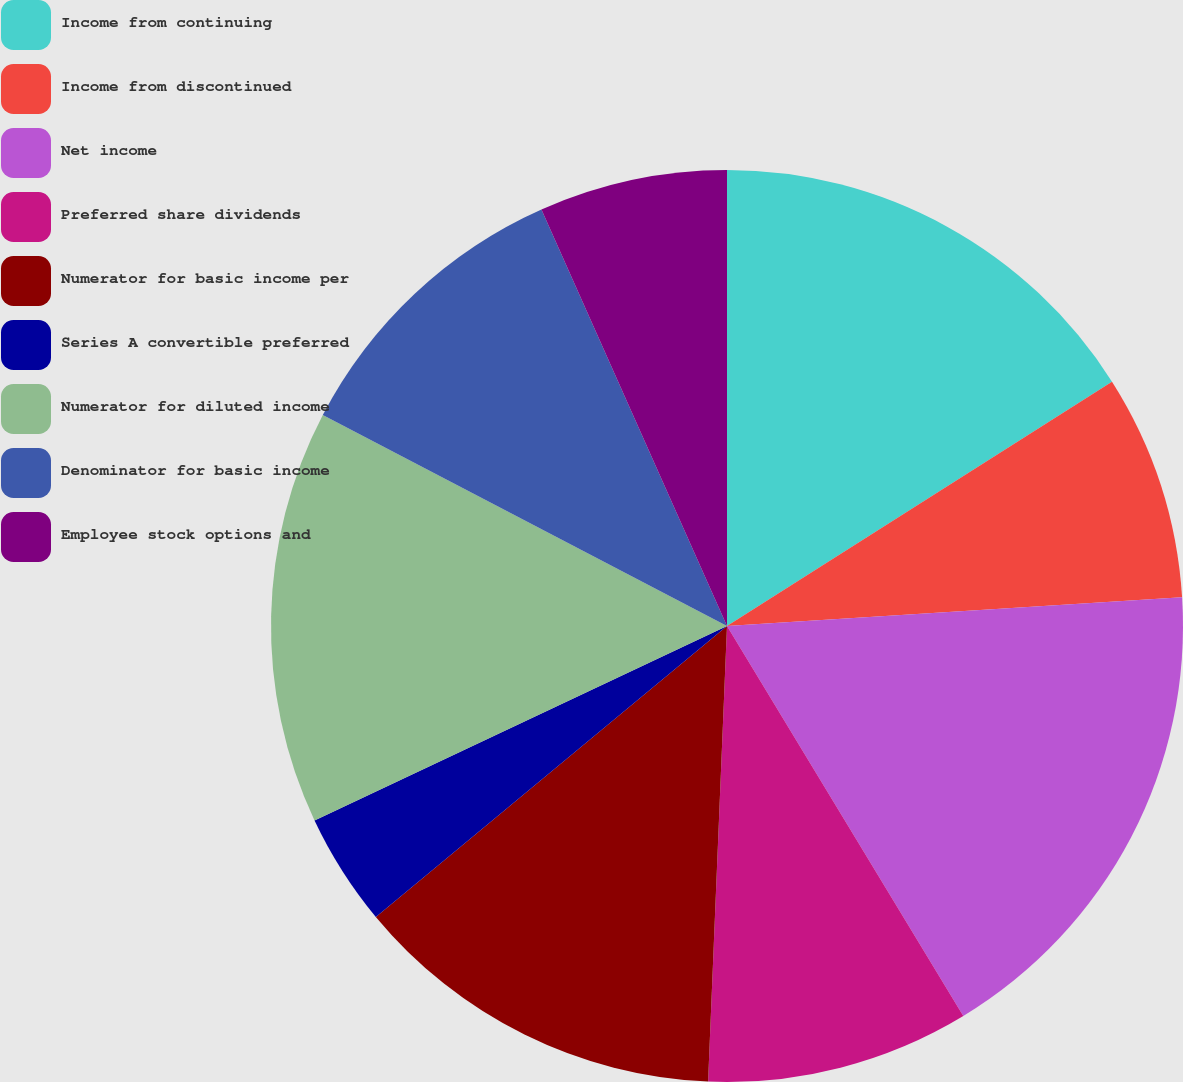Convert chart. <chart><loc_0><loc_0><loc_500><loc_500><pie_chart><fcel>Income from continuing<fcel>Income from discontinued<fcel>Net income<fcel>Preferred share dividends<fcel>Numerator for basic income per<fcel>Series A convertible preferred<fcel>Numerator for diluted income<fcel>Denominator for basic income<fcel>Employee stock options and<nl><fcel>16.0%<fcel>8.0%<fcel>17.33%<fcel>9.33%<fcel>13.33%<fcel>4.0%<fcel>14.67%<fcel>10.67%<fcel>6.67%<nl></chart> 